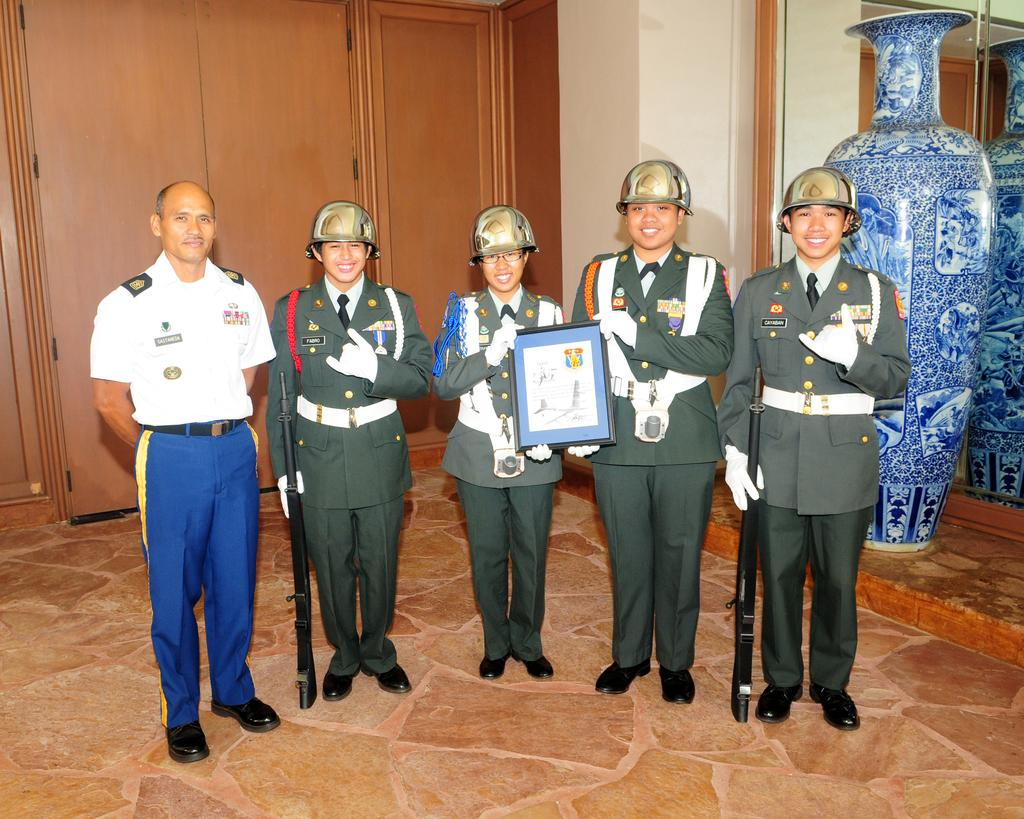How many people are present in the image? There are five people standing in the image. What are two of the people holding? Two of the people are holding guns. What are the other two people holding? Two of the people are holding a frame. What can be seen in the background of the image? There is a wall, a mirror, and a vase in the background of the image. What type of plastic is covering the cake in the image? There is no cake present in the image, so there is no plastic covering it. 